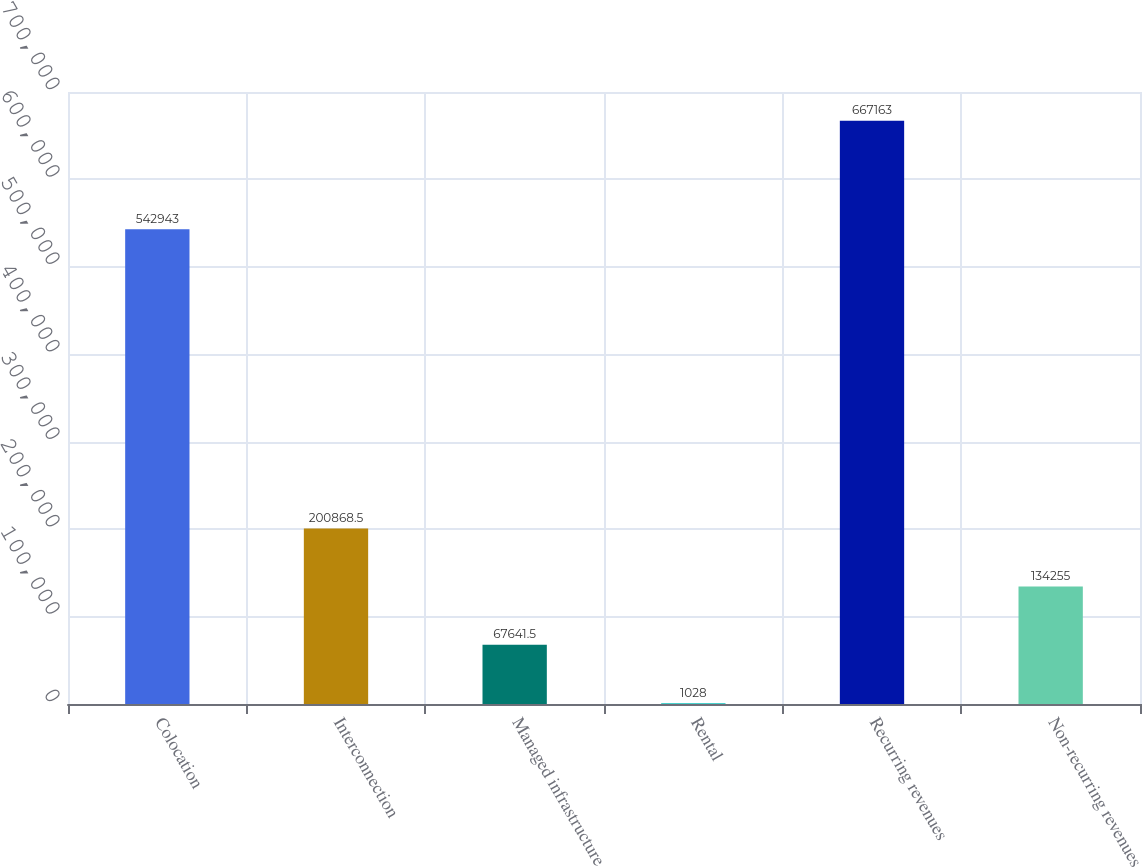Convert chart. <chart><loc_0><loc_0><loc_500><loc_500><bar_chart><fcel>Colocation<fcel>Interconnection<fcel>Managed infrastructure<fcel>Rental<fcel>Recurring revenues<fcel>Non-recurring revenues<nl><fcel>542943<fcel>200868<fcel>67641.5<fcel>1028<fcel>667163<fcel>134255<nl></chart> 